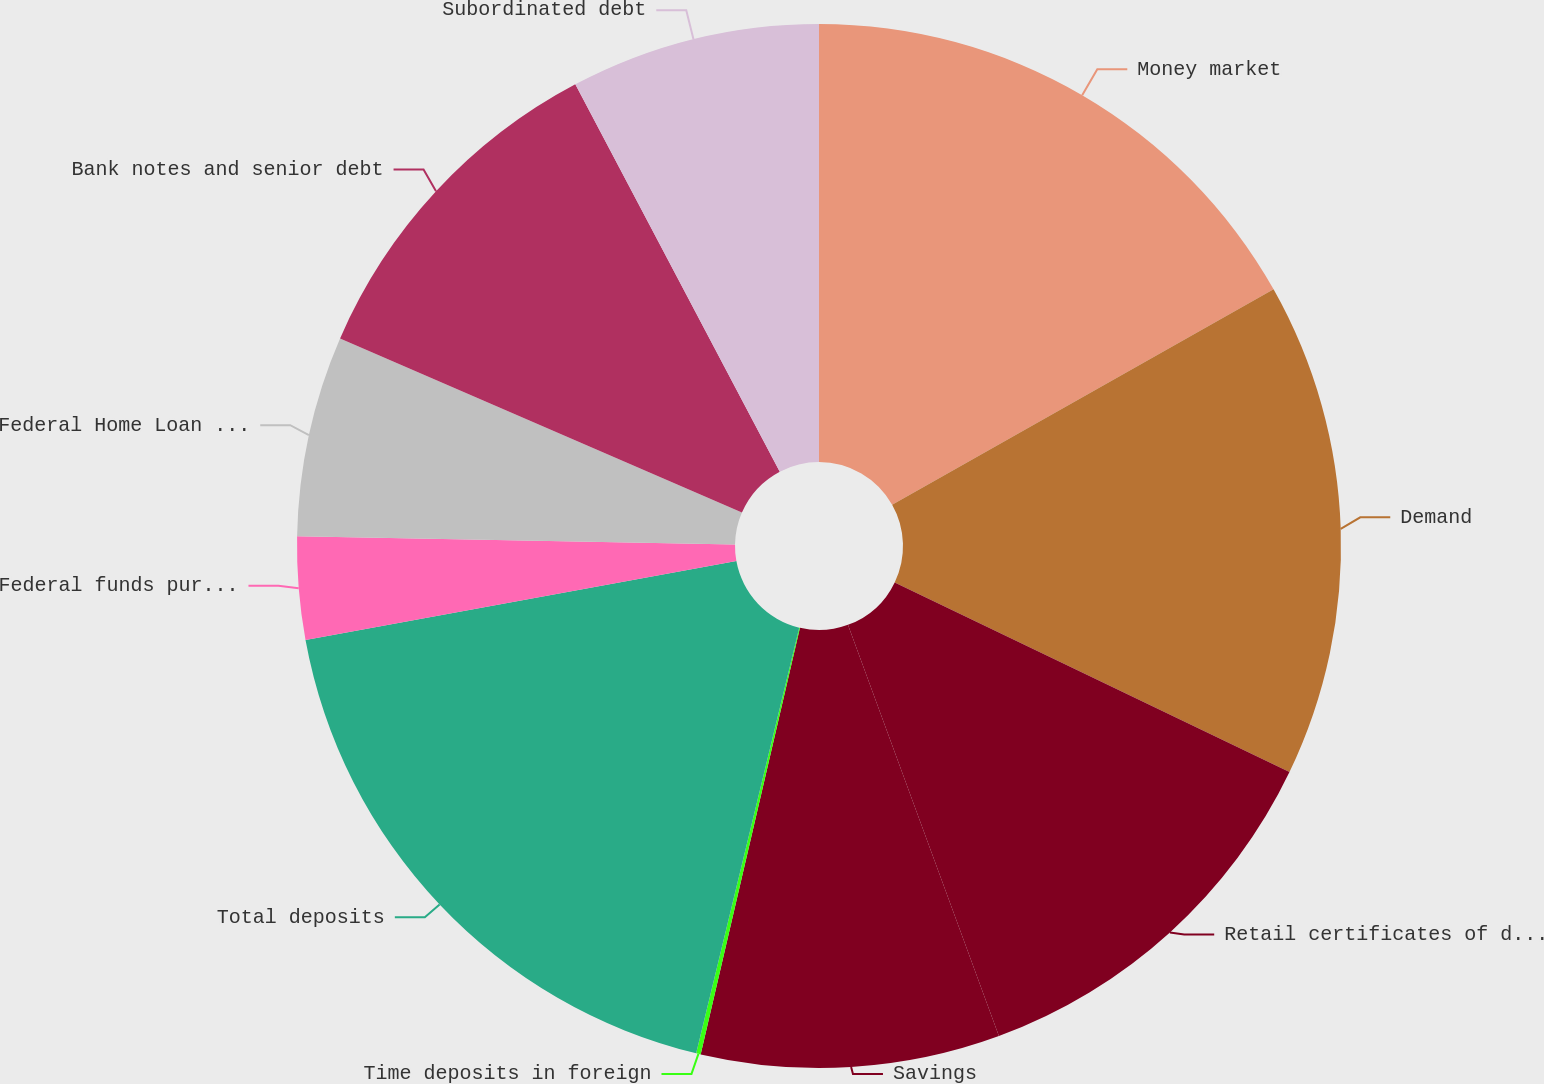Convert chart. <chart><loc_0><loc_0><loc_500><loc_500><pie_chart><fcel>Money market<fcel>Demand<fcel>Retail certificates of deposit<fcel>Savings<fcel>Time deposits in foreign<fcel>Total deposits<fcel>Federal funds purchased and<fcel>Federal Home Loan Bank<fcel>Bank notes and senior debt<fcel>Subordinated debt<nl><fcel>16.82%<fcel>15.31%<fcel>12.27%<fcel>9.24%<fcel>0.14%<fcel>18.34%<fcel>3.18%<fcel>6.21%<fcel>10.76%<fcel>7.73%<nl></chart> 